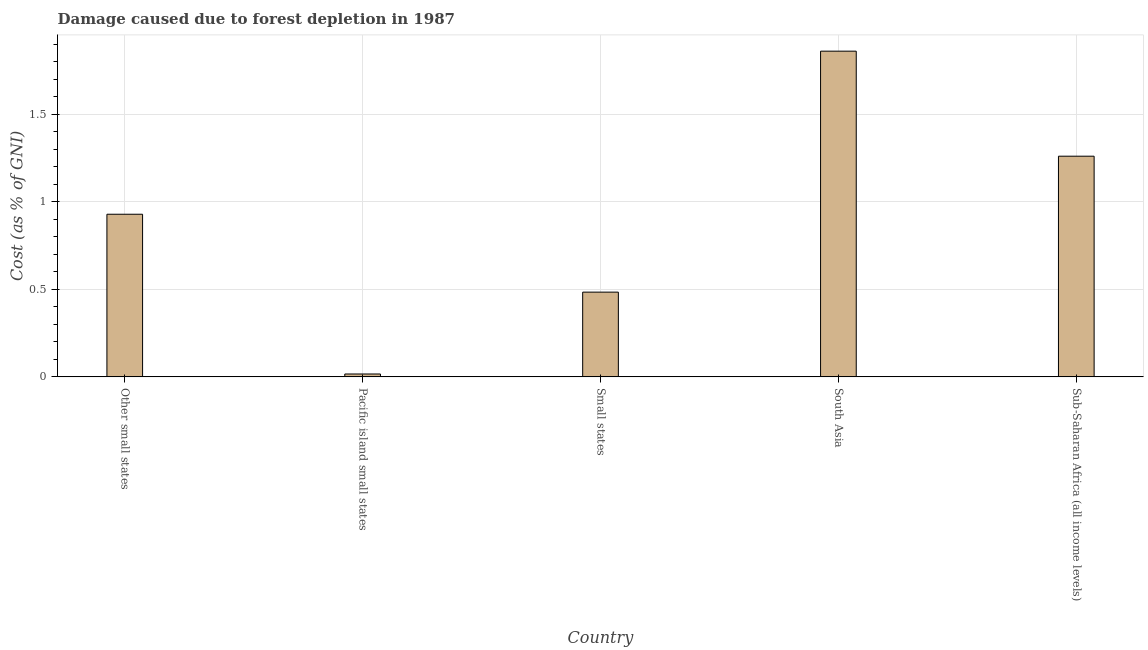Does the graph contain any zero values?
Make the answer very short. No. What is the title of the graph?
Provide a succinct answer. Damage caused due to forest depletion in 1987. What is the label or title of the X-axis?
Your answer should be compact. Country. What is the label or title of the Y-axis?
Your answer should be very brief. Cost (as % of GNI). What is the damage caused due to forest depletion in Other small states?
Offer a very short reply. 0.93. Across all countries, what is the maximum damage caused due to forest depletion?
Make the answer very short. 1.86. Across all countries, what is the minimum damage caused due to forest depletion?
Make the answer very short. 0.02. In which country was the damage caused due to forest depletion minimum?
Your response must be concise. Pacific island small states. What is the sum of the damage caused due to forest depletion?
Make the answer very short. 4.55. What is the difference between the damage caused due to forest depletion in Other small states and Pacific island small states?
Ensure brevity in your answer.  0.91. What is the average damage caused due to forest depletion per country?
Offer a very short reply. 0.91. What is the median damage caused due to forest depletion?
Keep it short and to the point. 0.93. In how many countries, is the damage caused due to forest depletion greater than 0.6 %?
Provide a succinct answer. 3. What is the ratio of the damage caused due to forest depletion in Small states to that in Sub-Saharan Africa (all income levels)?
Ensure brevity in your answer.  0.38. What is the difference between the highest and the second highest damage caused due to forest depletion?
Give a very brief answer. 0.6. What is the difference between the highest and the lowest damage caused due to forest depletion?
Ensure brevity in your answer.  1.84. In how many countries, is the damage caused due to forest depletion greater than the average damage caused due to forest depletion taken over all countries?
Make the answer very short. 3. How many bars are there?
Offer a terse response. 5. Are all the bars in the graph horizontal?
Provide a short and direct response. No. How many countries are there in the graph?
Give a very brief answer. 5. What is the difference between two consecutive major ticks on the Y-axis?
Offer a very short reply. 0.5. What is the Cost (as % of GNI) in Other small states?
Your answer should be very brief. 0.93. What is the Cost (as % of GNI) of Pacific island small states?
Offer a terse response. 0.02. What is the Cost (as % of GNI) in Small states?
Your answer should be very brief. 0.48. What is the Cost (as % of GNI) in South Asia?
Your response must be concise. 1.86. What is the Cost (as % of GNI) of Sub-Saharan Africa (all income levels)?
Your response must be concise. 1.26. What is the difference between the Cost (as % of GNI) in Other small states and Pacific island small states?
Offer a very short reply. 0.91. What is the difference between the Cost (as % of GNI) in Other small states and Small states?
Keep it short and to the point. 0.45. What is the difference between the Cost (as % of GNI) in Other small states and South Asia?
Your answer should be compact. -0.93. What is the difference between the Cost (as % of GNI) in Other small states and Sub-Saharan Africa (all income levels)?
Provide a short and direct response. -0.33. What is the difference between the Cost (as % of GNI) in Pacific island small states and Small states?
Your answer should be compact. -0.47. What is the difference between the Cost (as % of GNI) in Pacific island small states and South Asia?
Your response must be concise. -1.84. What is the difference between the Cost (as % of GNI) in Pacific island small states and Sub-Saharan Africa (all income levels)?
Make the answer very short. -1.24. What is the difference between the Cost (as % of GNI) in Small states and South Asia?
Your response must be concise. -1.38. What is the difference between the Cost (as % of GNI) in Small states and Sub-Saharan Africa (all income levels)?
Offer a very short reply. -0.78. What is the difference between the Cost (as % of GNI) in South Asia and Sub-Saharan Africa (all income levels)?
Your answer should be compact. 0.6. What is the ratio of the Cost (as % of GNI) in Other small states to that in Pacific island small states?
Your answer should be very brief. 56.57. What is the ratio of the Cost (as % of GNI) in Other small states to that in Small states?
Give a very brief answer. 1.92. What is the ratio of the Cost (as % of GNI) in Other small states to that in South Asia?
Provide a short and direct response. 0.5. What is the ratio of the Cost (as % of GNI) in Other small states to that in Sub-Saharan Africa (all income levels)?
Give a very brief answer. 0.74. What is the ratio of the Cost (as % of GNI) in Pacific island small states to that in Small states?
Offer a terse response. 0.03. What is the ratio of the Cost (as % of GNI) in Pacific island small states to that in South Asia?
Your answer should be very brief. 0.01. What is the ratio of the Cost (as % of GNI) in Pacific island small states to that in Sub-Saharan Africa (all income levels)?
Give a very brief answer. 0.01. What is the ratio of the Cost (as % of GNI) in Small states to that in South Asia?
Your answer should be very brief. 0.26. What is the ratio of the Cost (as % of GNI) in Small states to that in Sub-Saharan Africa (all income levels)?
Offer a very short reply. 0.38. What is the ratio of the Cost (as % of GNI) in South Asia to that in Sub-Saharan Africa (all income levels)?
Ensure brevity in your answer.  1.48. 